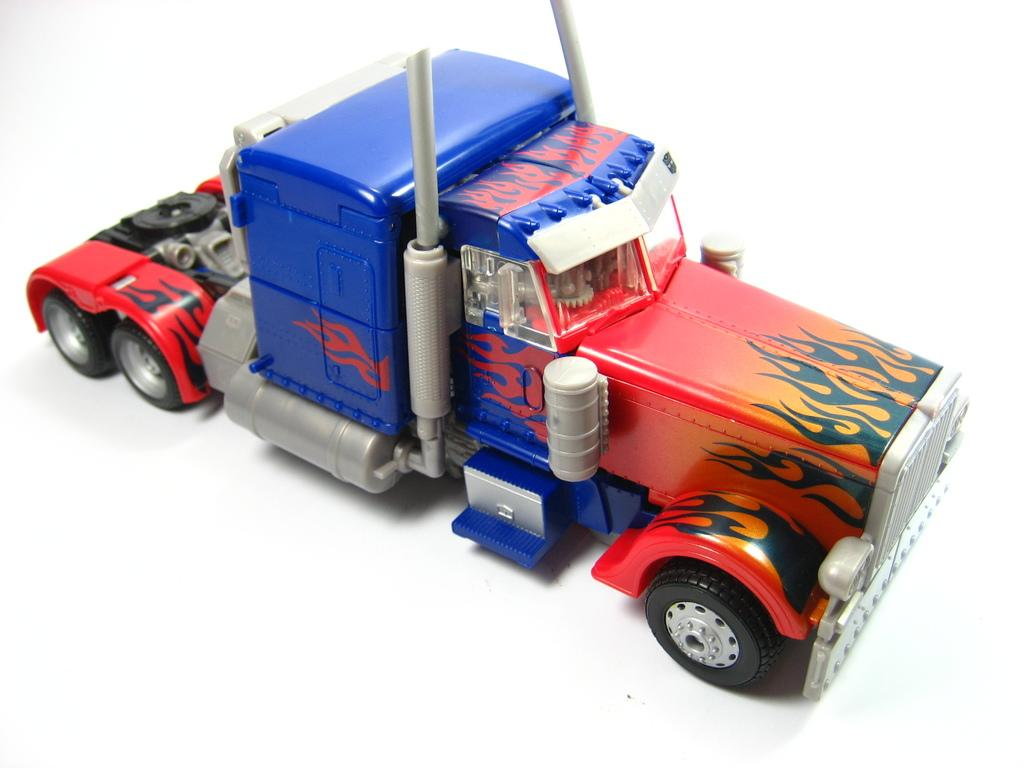What type of toy is present in the image? There is a toy vehicle in the image. What color is the surface beneath the toy vehicle? The surface beneath the toy vehicle is white. What type of question is being asked in the image? There is no question present in the image; it features a toy vehicle on a white surface. 